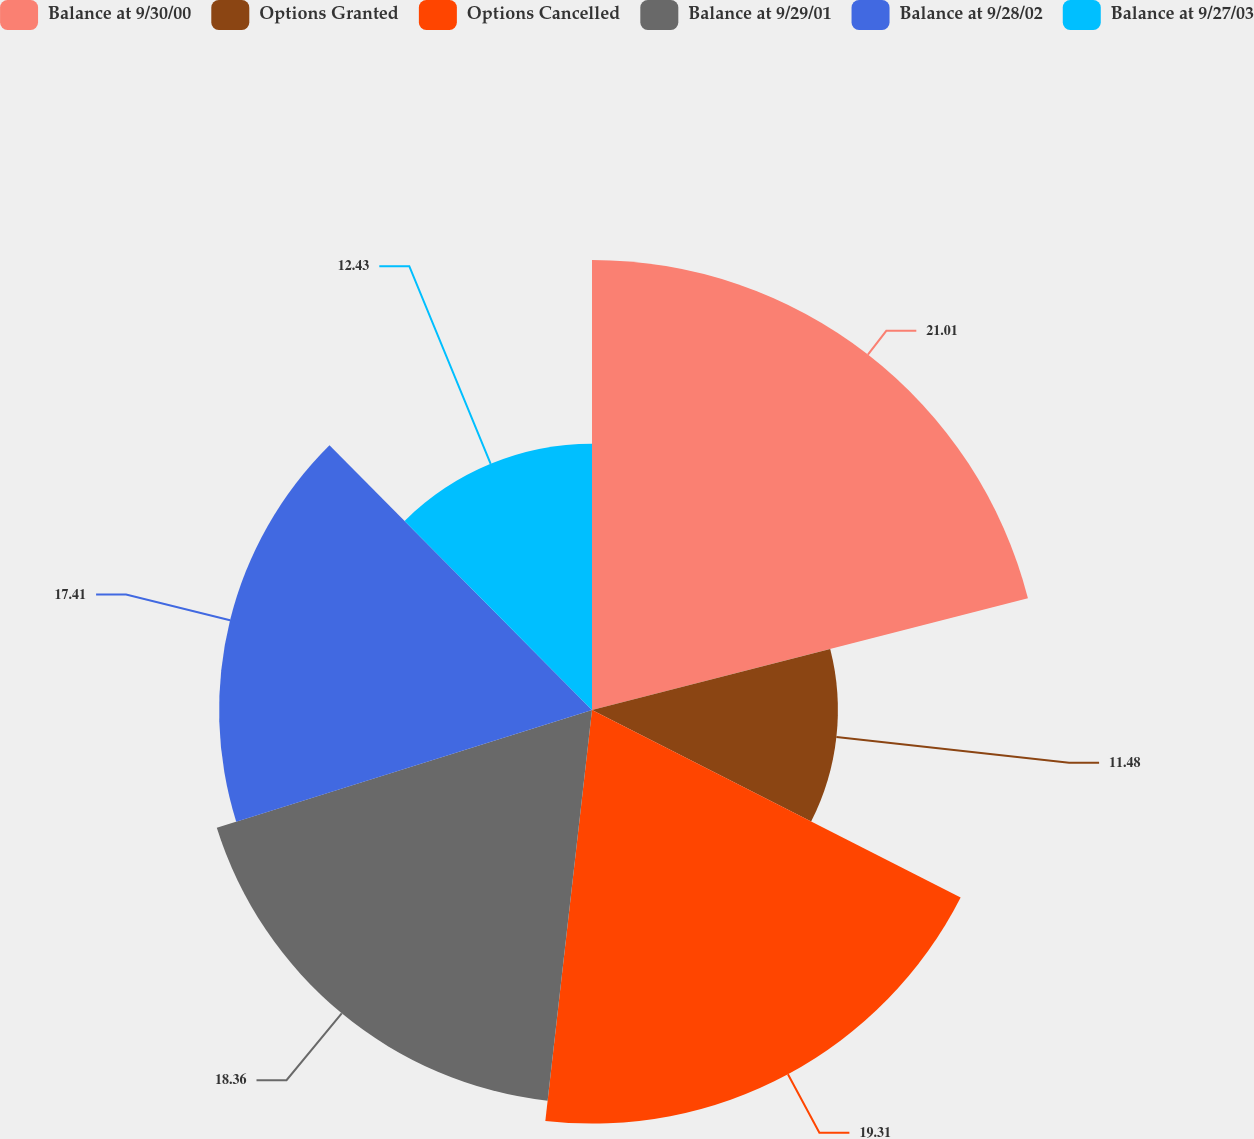<chart> <loc_0><loc_0><loc_500><loc_500><pie_chart><fcel>Balance at 9/30/00<fcel>Options Granted<fcel>Options Cancelled<fcel>Balance at 9/29/01<fcel>Balance at 9/28/02<fcel>Balance at 9/27/03<nl><fcel>21.01%<fcel>11.48%<fcel>19.31%<fcel>18.36%<fcel>17.41%<fcel>12.43%<nl></chart> 